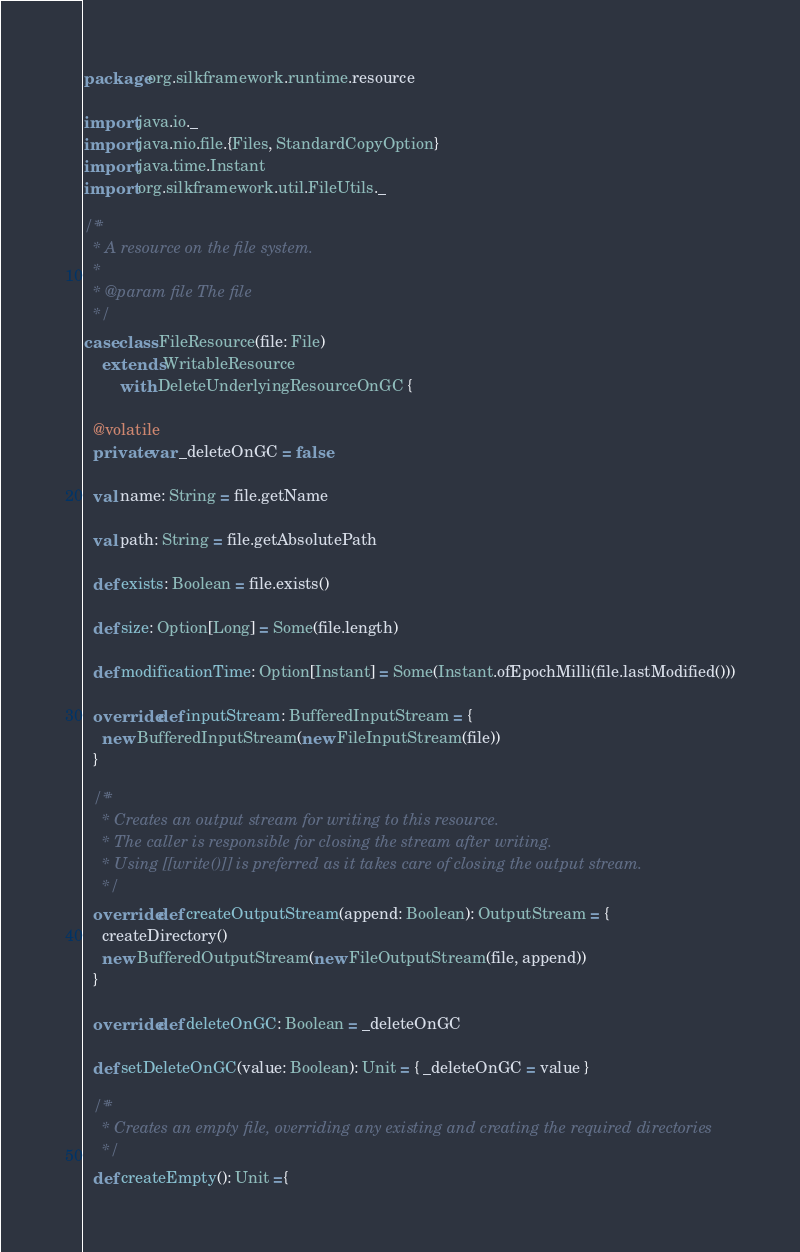Convert code to text. <code><loc_0><loc_0><loc_500><loc_500><_Scala_>package org.silkframework.runtime.resource

import java.io._
import java.nio.file.{Files, StandardCopyOption}
import java.time.Instant
import org.silkframework.util.FileUtils._

/**
  * A resource on the file system.
  *
  * @param file The file
  */
case class FileResource(file: File)
    extends WritableResource
        with DeleteUnderlyingResourceOnGC {

  @volatile
  private var _deleteOnGC = false

  val name: String = file.getName

  val path: String = file.getAbsolutePath

  def exists: Boolean = file.exists()

  def size: Option[Long] = Some(file.length)

  def modificationTime: Option[Instant] = Some(Instant.ofEpochMilli(file.lastModified()))

  override def inputStream: BufferedInputStream = {
    new BufferedInputStream(new FileInputStream(file))
  }

  /**
    * Creates an output stream for writing to this resource.
    * The caller is responsible for closing the stream after writing.
    * Using [[write()]] is preferred as it takes care of closing the output stream.
    */
  override def createOutputStream(append: Boolean): OutputStream = {
    createDirectory()
    new BufferedOutputStream(new FileOutputStream(file, append))
  }

  override def deleteOnGC: Boolean = _deleteOnGC

  def setDeleteOnGC(value: Boolean): Unit = { _deleteOnGC = value }

  /**
    * Creates an empty file, overriding any existing and creating the required directories
    */
  def createEmpty(): Unit ={</code> 